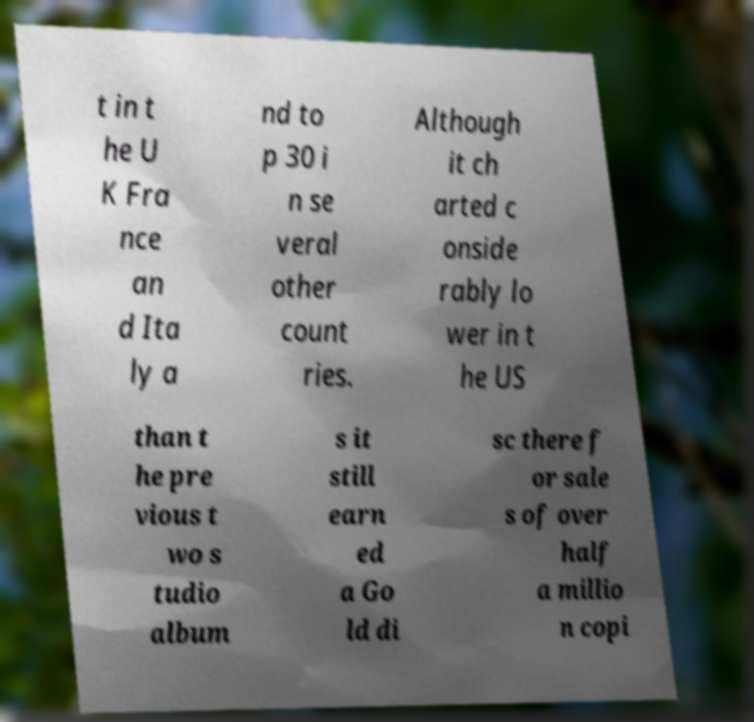Can you read and provide the text displayed in the image?This photo seems to have some interesting text. Can you extract and type it out for me? t in t he U K Fra nce an d Ita ly a nd to p 30 i n se veral other count ries. Although it ch arted c onside rably lo wer in t he US than t he pre vious t wo s tudio album s it still earn ed a Go ld di sc there f or sale s of over half a millio n copi 